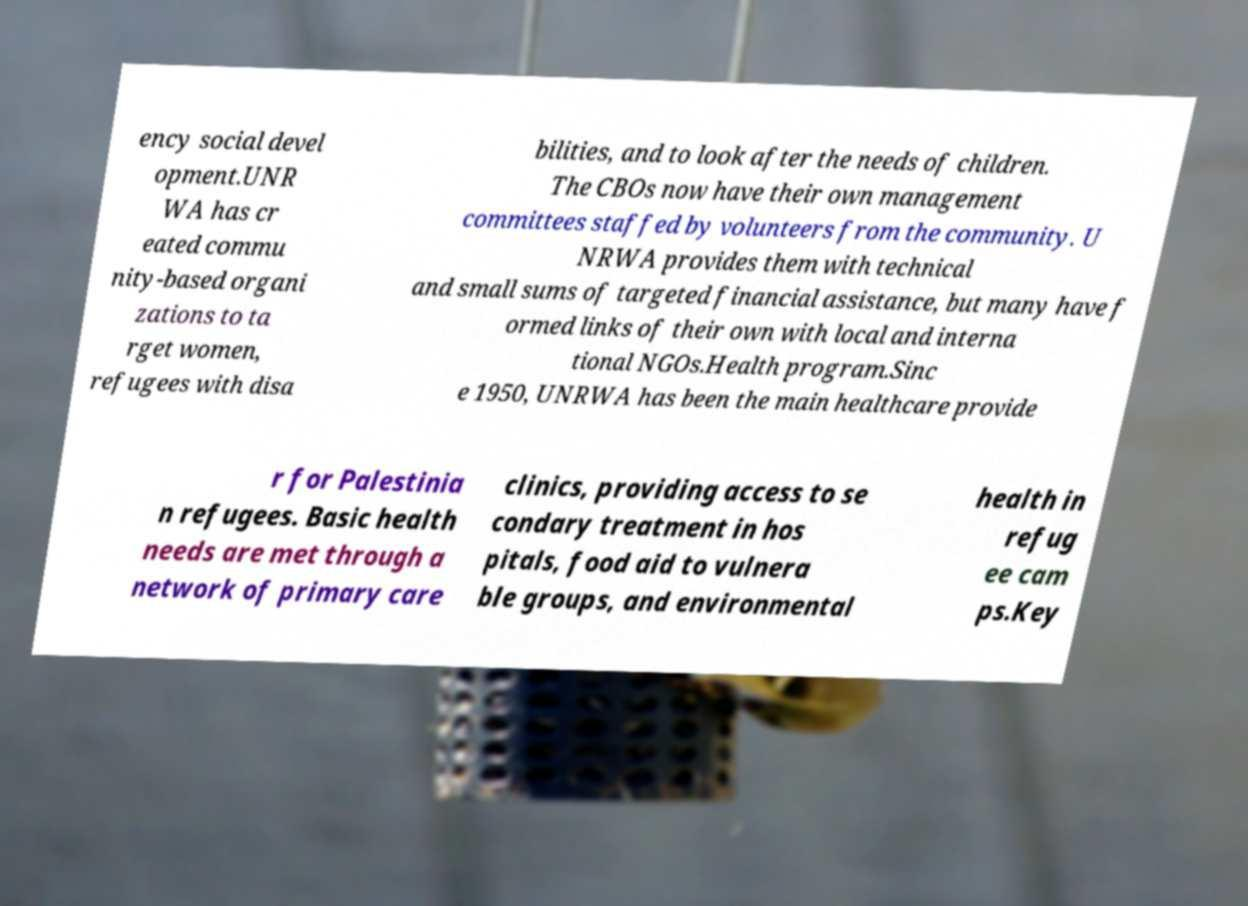Could you assist in decoding the text presented in this image and type it out clearly? ency social devel opment.UNR WA has cr eated commu nity-based organi zations to ta rget women, refugees with disa bilities, and to look after the needs of children. The CBOs now have their own management committees staffed by volunteers from the community. U NRWA provides them with technical and small sums of targeted financial assistance, but many have f ormed links of their own with local and interna tional NGOs.Health program.Sinc e 1950, UNRWA has been the main healthcare provide r for Palestinia n refugees. Basic health needs are met through a network of primary care clinics, providing access to se condary treatment in hos pitals, food aid to vulnera ble groups, and environmental health in refug ee cam ps.Key 